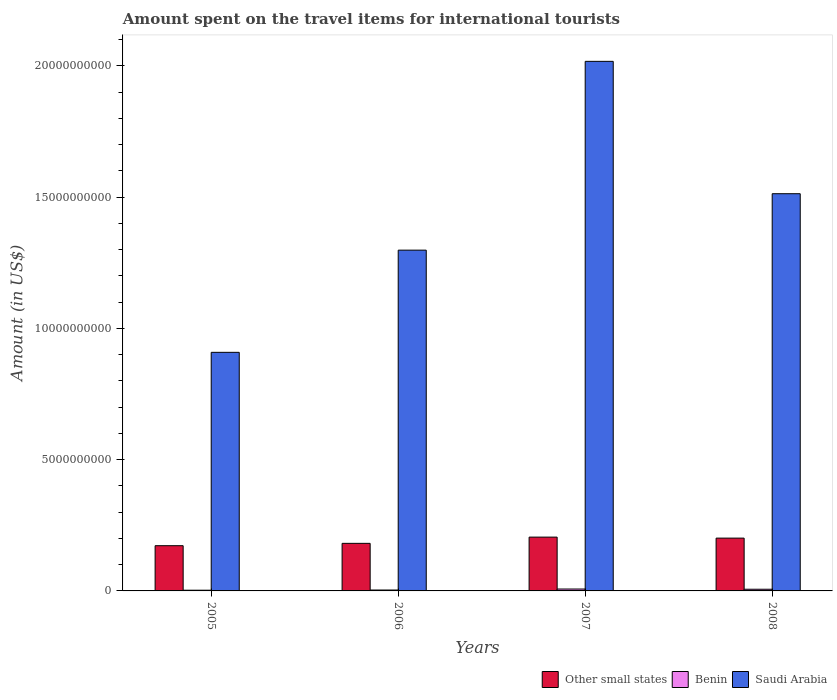How many different coloured bars are there?
Offer a very short reply. 3. How many groups of bars are there?
Your response must be concise. 4. Are the number of bars on each tick of the X-axis equal?
Keep it short and to the point. Yes. How many bars are there on the 3rd tick from the left?
Offer a very short reply. 3. What is the label of the 4th group of bars from the left?
Your answer should be compact. 2008. What is the amount spent on the travel items for international tourists in Saudi Arabia in 2006?
Your response must be concise. 1.30e+1. Across all years, what is the maximum amount spent on the travel items for international tourists in Saudi Arabia?
Your answer should be compact. 2.02e+1. Across all years, what is the minimum amount spent on the travel items for international tourists in Saudi Arabia?
Offer a terse response. 9.09e+09. In which year was the amount spent on the travel items for international tourists in Other small states minimum?
Your answer should be compact. 2005. What is the total amount spent on the travel items for international tourists in Saudi Arabia in the graph?
Provide a short and direct response. 5.74e+1. What is the difference between the amount spent on the travel items for international tourists in Benin in 2005 and that in 2007?
Give a very brief answer. -4.50e+07. What is the difference between the amount spent on the travel items for international tourists in Saudi Arabia in 2007 and the amount spent on the travel items for international tourists in Other small states in 2008?
Offer a terse response. 1.82e+1. What is the average amount spent on the travel items for international tourists in Other small states per year?
Offer a very short reply. 1.90e+09. In the year 2008, what is the difference between the amount spent on the travel items for international tourists in Other small states and amount spent on the travel items for international tourists in Saudi Arabia?
Your response must be concise. -1.31e+1. What is the ratio of the amount spent on the travel items for international tourists in Saudi Arabia in 2006 to that in 2007?
Provide a succinct answer. 0.64. Is the amount spent on the travel items for international tourists in Benin in 2006 less than that in 2008?
Ensure brevity in your answer.  Yes. What is the difference between the highest and the lowest amount spent on the travel items for international tourists in Other small states?
Your response must be concise. 3.27e+08. In how many years, is the amount spent on the travel items for international tourists in Other small states greater than the average amount spent on the travel items for international tourists in Other small states taken over all years?
Make the answer very short. 2. What does the 3rd bar from the left in 2006 represents?
Ensure brevity in your answer.  Saudi Arabia. What does the 2nd bar from the right in 2007 represents?
Your response must be concise. Benin. How many bars are there?
Give a very brief answer. 12. Are the values on the major ticks of Y-axis written in scientific E-notation?
Provide a short and direct response. No. Does the graph contain grids?
Keep it short and to the point. No. How many legend labels are there?
Provide a short and direct response. 3. What is the title of the graph?
Give a very brief answer. Amount spent on the travel items for international tourists. What is the label or title of the X-axis?
Ensure brevity in your answer.  Years. What is the label or title of the Y-axis?
Ensure brevity in your answer.  Amount (in US$). What is the Amount (in US$) of Other small states in 2005?
Your answer should be compact. 1.72e+09. What is the Amount (in US$) in Benin in 2005?
Provide a succinct answer. 2.70e+07. What is the Amount (in US$) in Saudi Arabia in 2005?
Your answer should be compact. 9.09e+09. What is the Amount (in US$) in Other small states in 2006?
Provide a succinct answer. 1.81e+09. What is the Amount (in US$) in Benin in 2006?
Offer a terse response. 3.40e+07. What is the Amount (in US$) of Saudi Arabia in 2006?
Give a very brief answer. 1.30e+1. What is the Amount (in US$) of Other small states in 2007?
Keep it short and to the point. 2.05e+09. What is the Amount (in US$) in Benin in 2007?
Keep it short and to the point. 7.20e+07. What is the Amount (in US$) in Saudi Arabia in 2007?
Give a very brief answer. 2.02e+1. What is the Amount (in US$) in Other small states in 2008?
Offer a very short reply. 2.01e+09. What is the Amount (in US$) of Benin in 2008?
Provide a short and direct response. 6.40e+07. What is the Amount (in US$) of Saudi Arabia in 2008?
Offer a terse response. 1.51e+1. Across all years, what is the maximum Amount (in US$) of Other small states?
Provide a succinct answer. 2.05e+09. Across all years, what is the maximum Amount (in US$) in Benin?
Offer a terse response. 7.20e+07. Across all years, what is the maximum Amount (in US$) of Saudi Arabia?
Provide a succinct answer. 2.02e+1. Across all years, what is the minimum Amount (in US$) in Other small states?
Provide a succinct answer. 1.72e+09. Across all years, what is the minimum Amount (in US$) in Benin?
Make the answer very short. 2.70e+07. Across all years, what is the minimum Amount (in US$) of Saudi Arabia?
Ensure brevity in your answer.  9.09e+09. What is the total Amount (in US$) in Other small states in the graph?
Provide a short and direct response. 7.59e+09. What is the total Amount (in US$) in Benin in the graph?
Offer a terse response. 1.97e+08. What is the total Amount (in US$) of Saudi Arabia in the graph?
Your answer should be compact. 5.74e+1. What is the difference between the Amount (in US$) of Other small states in 2005 and that in 2006?
Keep it short and to the point. -8.91e+07. What is the difference between the Amount (in US$) in Benin in 2005 and that in 2006?
Give a very brief answer. -7.00e+06. What is the difference between the Amount (in US$) in Saudi Arabia in 2005 and that in 2006?
Your answer should be very brief. -3.89e+09. What is the difference between the Amount (in US$) in Other small states in 2005 and that in 2007?
Provide a succinct answer. -3.27e+08. What is the difference between the Amount (in US$) in Benin in 2005 and that in 2007?
Provide a short and direct response. -4.50e+07. What is the difference between the Amount (in US$) of Saudi Arabia in 2005 and that in 2007?
Keep it short and to the point. -1.11e+1. What is the difference between the Amount (in US$) in Other small states in 2005 and that in 2008?
Offer a terse response. -2.89e+08. What is the difference between the Amount (in US$) of Benin in 2005 and that in 2008?
Your answer should be compact. -3.70e+07. What is the difference between the Amount (in US$) in Saudi Arabia in 2005 and that in 2008?
Keep it short and to the point. -6.04e+09. What is the difference between the Amount (in US$) in Other small states in 2006 and that in 2007?
Keep it short and to the point. -2.37e+08. What is the difference between the Amount (in US$) of Benin in 2006 and that in 2007?
Make the answer very short. -3.80e+07. What is the difference between the Amount (in US$) in Saudi Arabia in 2006 and that in 2007?
Provide a succinct answer. -7.19e+09. What is the difference between the Amount (in US$) in Other small states in 2006 and that in 2008?
Offer a terse response. -2.00e+08. What is the difference between the Amount (in US$) in Benin in 2006 and that in 2008?
Give a very brief answer. -3.00e+07. What is the difference between the Amount (in US$) of Saudi Arabia in 2006 and that in 2008?
Your answer should be very brief. -2.15e+09. What is the difference between the Amount (in US$) in Other small states in 2007 and that in 2008?
Give a very brief answer. 3.79e+07. What is the difference between the Amount (in US$) of Benin in 2007 and that in 2008?
Keep it short and to the point. 8.00e+06. What is the difference between the Amount (in US$) of Saudi Arabia in 2007 and that in 2008?
Offer a terse response. 5.04e+09. What is the difference between the Amount (in US$) of Other small states in 2005 and the Amount (in US$) of Benin in 2006?
Provide a succinct answer. 1.69e+09. What is the difference between the Amount (in US$) in Other small states in 2005 and the Amount (in US$) in Saudi Arabia in 2006?
Make the answer very short. -1.13e+1. What is the difference between the Amount (in US$) in Benin in 2005 and the Amount (in US$) in Saudi Arabia in 2006?
Ensure brevity in your answer.  -1.30e+1. What is the difference between the Amount (in US$) of Other small states in 2005 and the Amount (in US$) of Benin in 2007?
Your answer should be very brief. 1.65e+09. What is the difference between the Amount (in US$) in Other small states in 2005 and the Amount (in US$) in Saudi Arabia in 2007?
Make the answer very short. -1.84e+1. What is the difference between the Amount (in US$) in Benin in 2005 and the Amount (in US$) in Saudi Arabia in 2007?
Your answer should be very brief. -2.01e+1. What is the difference between the Amount (in US$) in Other small states in 2005 and the Amount (in US$) in Benin in 2008?
Provide a succinct answer. 1.66e+09. What is the difference between the Amount (in US$) of Other small states in 2005 and the Amount (in US$) of Saudi Arabia in 2008?
Give a very brief answer. -1.34e+1. What is the difference between the Amount (in US$) in Benin in 2005 and the Amount (in US$) in Saudi Arabia in 2008?
Your response must be concise. -1.51e+1. What is the difference between the Amount (in US$) in Other small states in 2006 and the Amount (in US$) in Benin in 2007?
Offer a terse response. 1.74e+09. What is the difference between the Amount (in US$) in Other small states in 2006 and the Amount (in US$) in Saudi Arabia in 2007?
Give a very brief answer. -1.84e+1. What is the difference between the Amount (in US$) of Benin in 2006 and the Amount (in US$) of Saudi Arabia in 2007?
Keep it short and to the point. -2.01e+1. What is the difference between the Amount (in US$) of Other small states in 2006 and the Amount (in US$) of Benin in 2008?
Your answer should be very brief. 1.75e+09. What is the difference between the Amount (in US$) of Other small states in 2006 and the Amount (in US$) of Saudi Arabia in 2008?
Your answer should be compact. -1.33e+1. What is the difference between the Amount (in US$) of Benin in 2006 and the Amount (in US$) of Saudi Arabia in 2008?
Offer a terse response. -1.51e+1. What is the difference between the Amount (in US$) in Other small states in 2007 and the Amount (in US$) in Benin in 2008?
Provide a succinct answer. 1.99e+09. What is the difference between the Amount (in US$) of Other small states in 2007 and the Amount (in US$) of Saudi Arabia in 2008?
Your response must be concise. -1.31e+1. What is the difference between the Amount (in US$) of Benin in 2007 and the Amount (in US$) of Saudi Arabia in 2008?
Provide a short and direct response. -1.51e+1. What is the average Amount (in US$) of Other small states per year?
Your answer should be compact. 1.90e+09. What is the average Amount (in US$) in Benin per year?
Make the answer very short. 4.92e+07. What is the average Amount (in US$) in Saudi Arabia per year?
Give a very brief answer. 1.43e+1. In the year 2005, what is the difference between the Amount (in US$) of Other small states and Amount (in US$) of Benin?
Your response must be concise. 1.70e+09. In the year 2005, what is the difference between the Amount (in US$) of Other small states and Amount (in US$) of Saudi Arabia?
Provide a succinct answer. -7.36e+09. In the year 2005, what is the difference between the Amount (in US$) of Benin and Amount (in US$) of Saudi Arabia?
Offer a very short reply. -9.06e+09. In the year 2006, what is the difference between the Amount (in US$) in Other small states and Amount (in US$) in Benin?
Give a very brief answer. 1.78e+09. In the year 2006, what is the difference between the Amount (in US$) in Other small states and Amount (in US$) in Saudi Arabia?
Make the answer very short. -1.12e+1. In the year 2006, what is the difference between the Amount (in US$) of Benin and Amount (in US$) of Saudi Arabia?
Give a very brief answer. -1.29e+1. In the year 2007, what is the difference between the Amount (in US$) in Other small states and Amount (in US$) in Benin?
Offer a very short reply. 1.98e+09. In the year 2007, what is the difference between the Amount (in US$) in Other small states and Amount (in US$) in Saudi Arabia?
Provide a succinct answer. -1.81e+1. In the year 2007, what is the difference between the Amount (in US$) in Benin and Amount (in US$) in Saudi Arabia?
Offer a terse response. -2.01e+1. In the year 2008, what is the difference between the Amount (in US$) in Other small states and Amount (in US$) in Benin?
Ensure brevity in your answer.  1.95e+09. In the year 2008, what is the difference between the Amount (in US$) of Other small states and Amount (in US$) of Saudi Arabia?
Your response must be concise. -1.31e+1. In the year 2008, what is the difference between the Amount (in US$) in Benin and Amount (in US$) in Saudi Arabia?
Your answer should be compact. -1.51e+1. What is the ratio of the Amount (in US$) in Other small states in 2005 to that in 2006?
Your answer should be compact. 0.95. What is the ratio of the Amount (in US$) of Benin in 2005 to that in 2006?
Your response must be concise. 0.79. What is the ratio of the Amount (in US$) in Saudi Arabia in 2005 to that in 2006?
Offer a terse response. 0.7. What is the ratio of the Amount (in US$) of Other small states in 2005 to that in 2007?
Provide a short and direct response. 0.84. What is the ratio of the Amount (in US$) of Benin in 2005 to that in 2007?
Offer a very short reply. 0.38. What is the ratio of the Amount (in US$) in Saudi Arabia in 2005 to that in 2007?
Offer a terse response. 0.45. What is the ratio of the Amount (in US$) of Other small states in 2005 to that in 2008?
Keep it short and to the point. 0.86. What is the ratio of the Amount (in US$) of Benin in 2005 to that in 2008?
Your answer should be very brief. 0.42. What is the ratio of the Amount (in US$) of Saudi Arabia in 2005 to that in 2008?
Provide a succinct answer. 0.6. What is the ratio of the Amount (in US$) in Other small states in 2006 to that in 2007?
Provide a succinct answer. 0.88. What is the ratio of the Amount (in US$) of Benin in 2006 to that in 2007?
Your response must be concise. 0.47. What is the ratio of the Amount (in US$) of Saudi Arabia in 2006 to that in 2007?
Your answer should be compact. 0.64. What is the ratio of the Amount (in US$) of Other small states in 2006 to that in 2008?
Make the answer very short. 0.9. What is the ratio of the Amount (in US$) in Benin in 2006 to that in 2008?
Provide a short and direct response. 0.53. What is the ratio of the Amount (in US$) in Saudi Arabia in 2006 to that in 2008?
Ensure brevity in your answer.  0.86. What is the ratio of the Amount (in US$) in Other small states in 2007 to that in 2008?
Offer a terse response. 1.02. What is the ratio of the Amount (in US$) in Benin in 2007 to that in 2008?
Your answer should be very brief. 1.12. What is the ratio of the Amount (in US$) of Saudi Arabia in 2007 to that in 2008?
Provide a short and direct response. 1.33. What is the difference between the highest and the second highest Amount (in US$) in Other small states?
Offer a terse response. 3.79e+07. What is the difference between the highest and the second highest Amount (in US$) in Saudi Arabia?
Give a very brief answer. 5.04e+09. What is the difference between the highest and the lowest Amount (in US$) in Other small states?
Offer a very short reply. 3.27e+08. What is the difference between the highest and the lowest Amount (in US$) in Benin?
Give a very brief answer. 4.50e+07. What is the difference between the highest and the lowest Amount (in US$) of Saudi Arabia?
Your answer should be compact. 1.11e+1. 